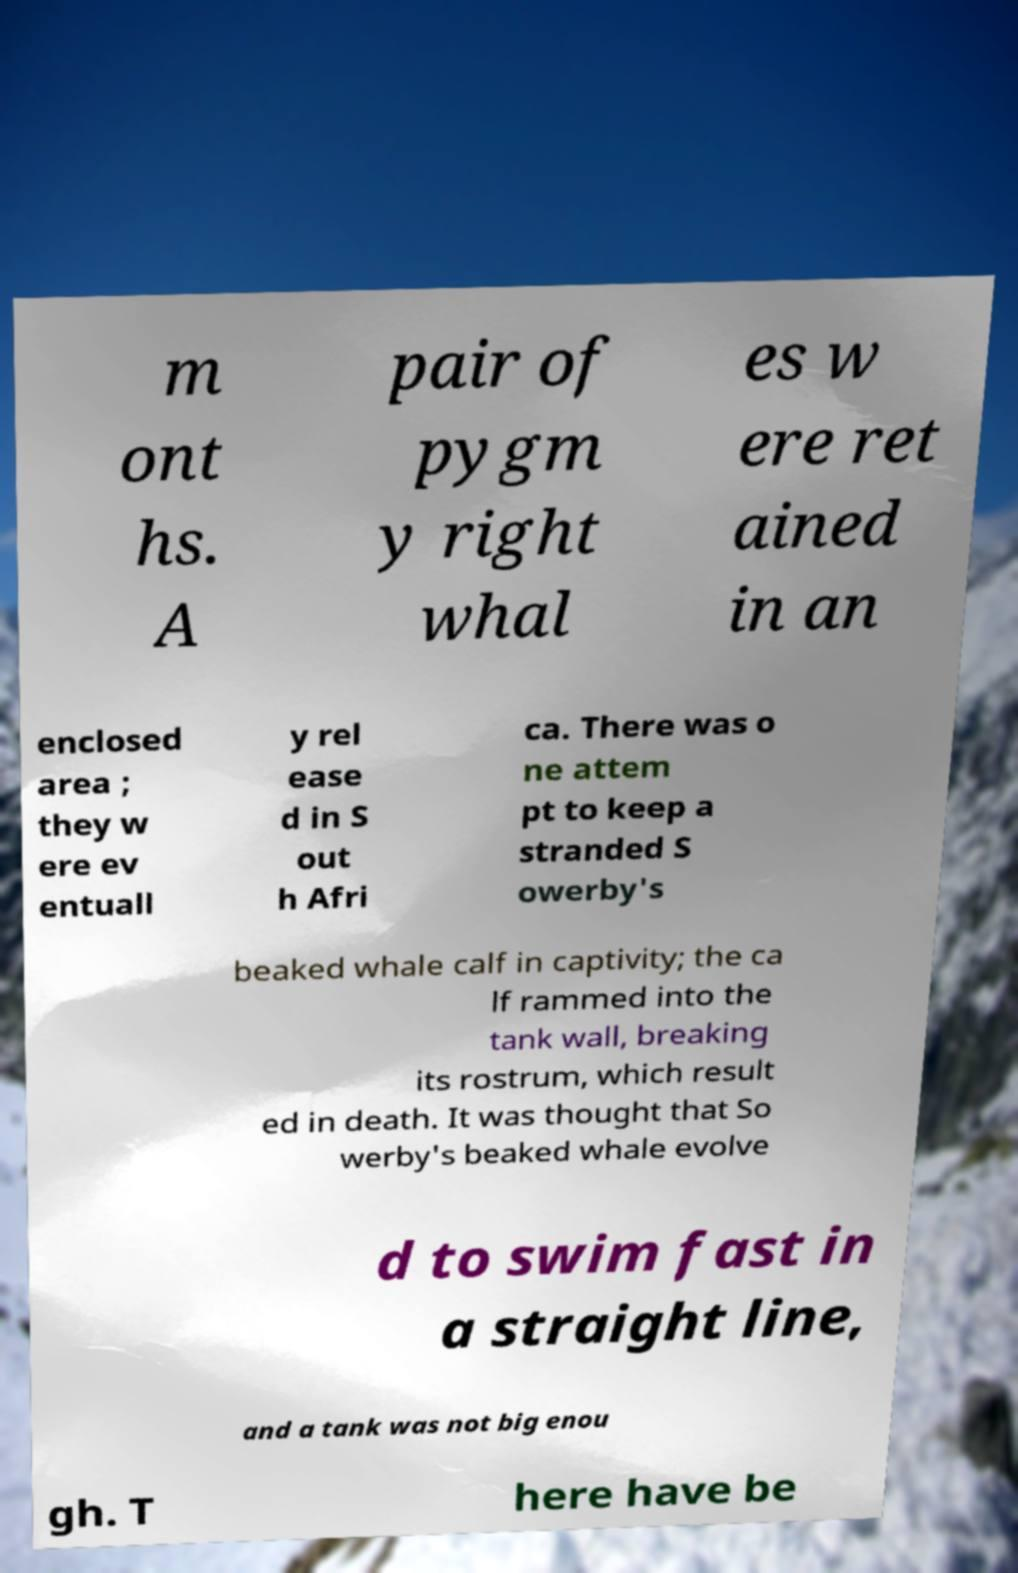Could you assist in decoding the text presented in this image and type it out clearly? m ont hs. A pair of pygm y right whal es w ere ret ained in an enclosed area ; they w ere ev entuall y rel ease d in S out h Afri ca. There was o ne attem pt to keep a stranded S owerby's beaked whale calf in captivity; the ca lf rammed into the tank wall, breaking its rostrum, which result ed in death. It was thought that So werby's beaked whale evolve d to swim fast in a straight line, and a tank was not big enou gh. T here have be 